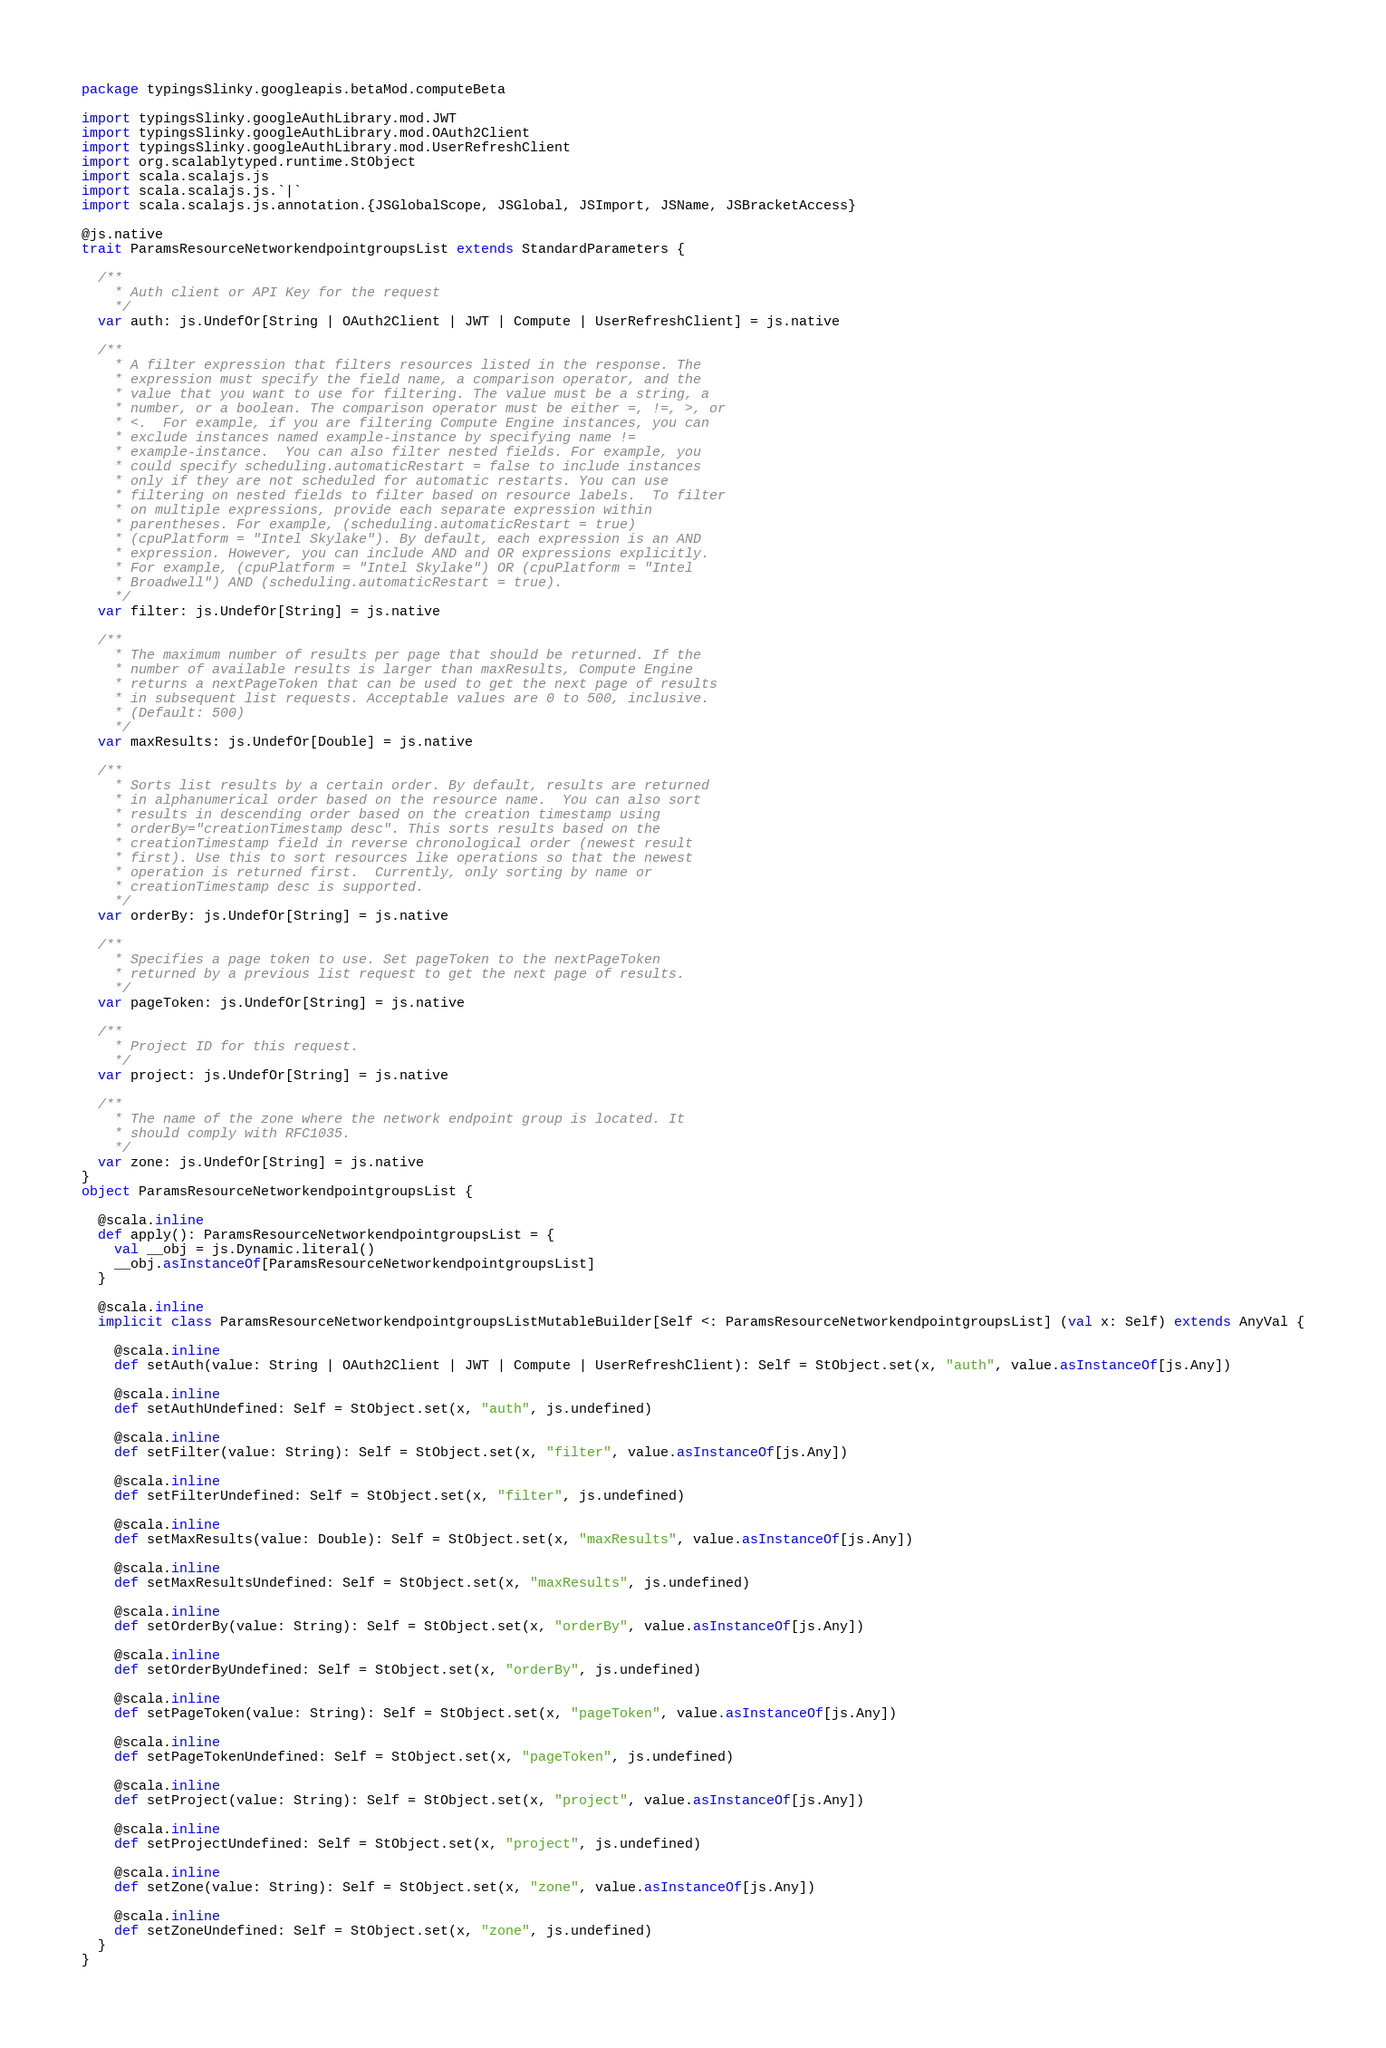Convert code to text. <code><loc_0><loc_0><loc_500><loc_500><_Scala_>package typingsSlinky.googleapis.betaMod.computeBeta

import typingsSlinky.googleAuthLibrary.mod.JWT
import typingsSlinky.googleAuthLibrary.mod.OAuth2Client
import typingsSlinky.googleAuthLibrary.mod.UserRefreshClient
import org.scalablytyped.runtime.StObject
import scala.scalajs.js
import scala.scalajs.js.`|`
import scala.scalajs.js.annotation.{JSGlobalScope, JSGlobal, JSImport, JSName, JSBracketAccess}

@js.native
trait ParamsResourceNetworkendpointgroupsList extends StandardParameters {
  
  /**
    * Auth client or API Key for the request
    */
  var auth: js.UndefOr[String | OAuth2Client | JWT | Compute | UserRefreshClient] = js.native
  
  /**
    * A filter expression that filters resources listed in the response. The
    * expression must specify the field name, a comparison operator, and the
    * value that you want to use for filtering. The value must be a string, a
    * number, or a boolean. The comparison operator must be either =, !=, >, or
    * <.  For example, if you are filtering Compute Engine instances, you can
    * exclude instances named example-instance by specifying name !=
    * example-instance.  You can also filter nested fields. For example, you
    * could specify scheduling.automaticRestart = false to include instances
    * only if they are not scheduled for automatic restarts. You can use
    * filtering on nested fields to filter based on resource labels.  To filter
    * on multiple expressions, provide each separate expression within
    * parentheses. For example, (scheduling.automaticRestart = true)
    * (cpuPlatform = "Intel Skylake"). By default, each expression is an AND
    * expression. However, you can include AND and OR expressions explicitly.
    * For example, (cpuPlatform = "Intel Skylake") OR (cpuPlatform = "Intel
    * Broadwell") AND (scheduling.automaticRestart = true).
    */
  var filter: js.UndefOr[String] = js.native
  
  /**
    * The maximum number of results per page that should be returned. If the
    * number of available results is larger than maxResults, Compute Engine
    * returns a nextPageToken that can be used to get the next page of results
    * in subsequent list requests. Acceptable values are 0 to 500, inclusive.
    * (Default: 500)
    */
  var maxResults: js.UndefOr[Double] = js.native
  
  /**
    * Sorts list results by a certain order. By default, results are returned
    * in alphanumerical order based on the resource name.  You can also sort
    * results in descending order based on the creation timestamp using
    * orderBy="creationTimestamp desc". This sorts results based on the
    * creationTimestamp field in reverse chronological order (newest result
    * first). Use this to sort resources like operations so that the newest
    * operation is returned first.  Currently, only sorting by name or
    * creationTimestamp desc is supported.
    */
  var orderBy: js.UndefOr[String] = js.native
  
  /**
    * Specifies a page token to use. Set pageToken to the nextPageToken
    * returned by a previous list request to get the next page of results.
    */
  var pageToken: js.UndefOr[String] = js.native
  
  /**
    * Project ID for this request.
    */
  var project: js.UndefOr[String] = js.native
  
  /**
    * The name of the zone where the network endpoint group is located. It
    * should comply with RFC1035.
    */
  var zone: js.UndefOr[String] = js.native
}
object ParamsResourceNetworkendpointgroupsList {
  
  @scala.inline
  def apply(): ParamsResourceNetworkendpointgroupsList = {
    val __obj = js.Dynamic.literal()
    __obj.asInstanceOf[ParamsResourceNetworkendpointgroupsList]
  }
  
  @scala.inline
  implicit class ParamsResourceNetworkendpointgroupsListMutableBuilder[Self <: ParamsResourceNetworkendpointgroupsList] (val x: Self) extends AnyVal {
    
    @scala.inline
    def setAuth(value: String | OAuth2Client | JWT | Compute | UserRefreshClient): Self = StObject.set(x, "auth", value.asInstanceOf[js.Any])
    
    @scala.inline
    def setAuthUndefined: Self = StObject.set(x, "auth", js.undefined)
    
    @scala.inline
    def setFilter(value: String): Self = StObject.set(x, "filter", value.asInstanceOf[js.Any])
    
    @scala.inline
    def setFilterUndefined: Self = StObject.set(x, "filter", js.undefined)
    
    @scala.inline
    def setMaxResults(value: Double): Self = StObject.set(x, "maxResults", value.asInstanceOf[js.Any])
    
    @scala.inline
    def setMaxResultsUndefined: Self = StObject.set(x, "maxResults", js.undefined)
    
    @scala.inline
    def setOrderBy(value: String): Self = StObject.set(x, "orderBy", value.asInstanceOf[js.Any])
    
    @scala.inline
    def setOrderByUndefined: Self = StObject.set(x, "orderBy", js.undefined)
    
    @scala.inline
    def setPageToken(value: String): Self = StObject.set(x, "pageToken", value.asInstanceOf[js.Any])
    
    @scala.inline
    def setPageTokenUndefined: Self = StObject.set(x, "pageToken", js.undefined)
    
    @scala.inline
    def setProject(value: String): Self = StObject.set(x, "project", value.asInstanceOf[js.Any])
    
    @scala.inline
    def setProjectUndefined: Self = StObject.set(x, "project", js.undefined)
    
    @scala.inline
    def setZone(value: String): Self = StObject.set(x, "zone", value.asInstanceOf[js.Any])
    
    @scala.inline
    def setZoneUndefined: Self = StObject.set(x, "zone", js.undefined)
  }
}
</code> 